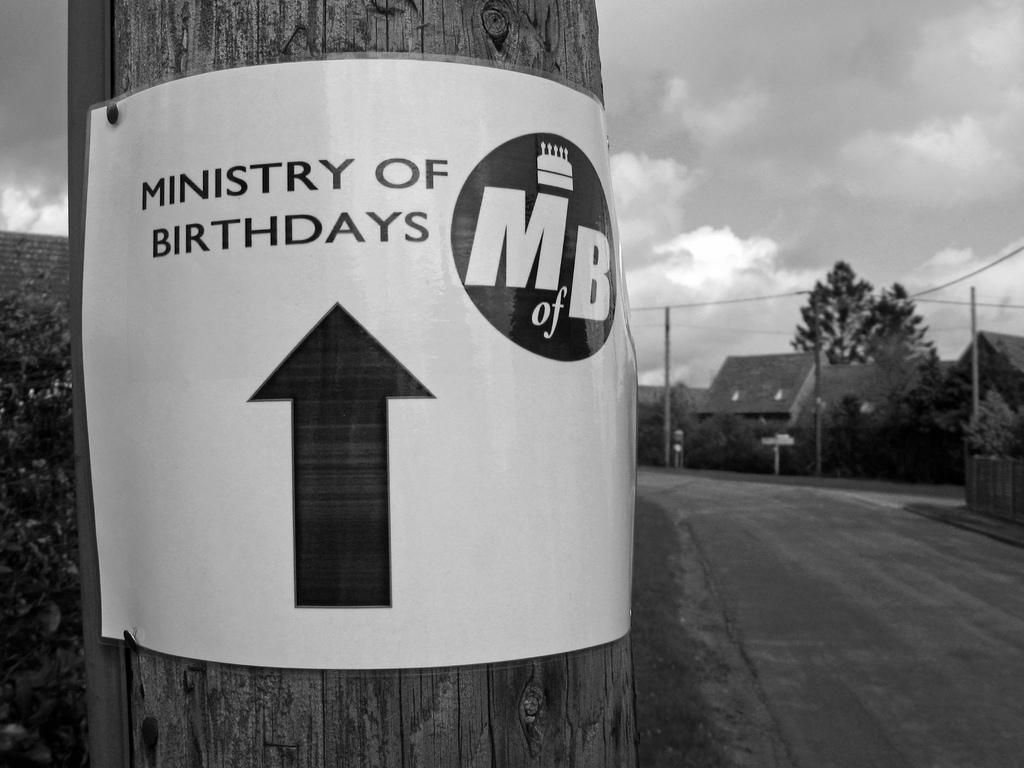Provide a one-sentence caption for the provided image. A sign pointing towards the ministry of birthdays is posted to a telephone pole. 